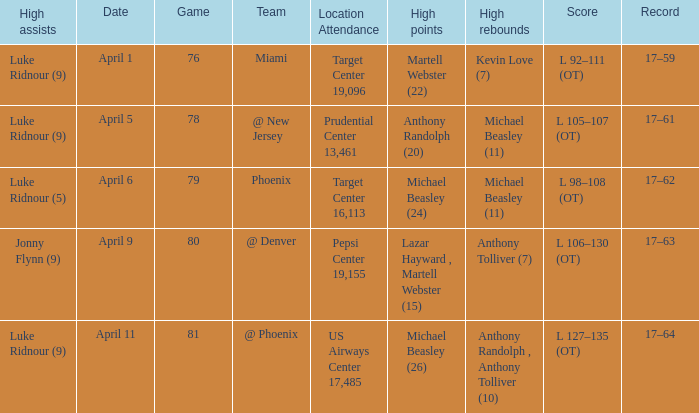How many different results for high rebounds were there for game number 76? 1.0. Write the full table. {'header': ['High assists', 'Date', 'Game', 'Team', 'Location Attendance', 'High points', 'High rebounds', 'Score', 'Record'], 'rows': [['Luke Ridnour (9)', 'April 1', '76', 'Miami', 'Target Center 19,096', 'Martell Webster (22)', 'Kevin Love (7)', 'L 92–111 (OT)', '17–59'], ['Luke Ridnour (9)', 'April 5', '78', '@ New Jersey', 'Prudential Center 13,461', 'Anthony Randolph (20)', 'Michael Beasley (11)', 'L 105–107 (OT)', '17–61'], ['Luke Ridnour (5)', 'April 6', '79', 'Phoenix', 'Target Center 16,113', 'Michael Beasley (24)', 'Michael Beasley (11)', 'L 98–108 (OT)', '17–62'], ['Jonny Flynn (9)', 'April 9', '80', '@ Denver', 'Pepsi Center 19,155', 'Lazar Hayward , Martell Webster (15)', 'Anthony Tolliver (7)', 'L 106–130 (OT)', '17–63'], ['Luke Ridnour (9)', 'April 11', '81', '@ Phoenix', 'US Airways Center 17,485', 'Michael Beasley (26)', 'Anthony Randolph , Anthony Tolliver (10)', 'L 127–135 (OT)', '17–64']]} 